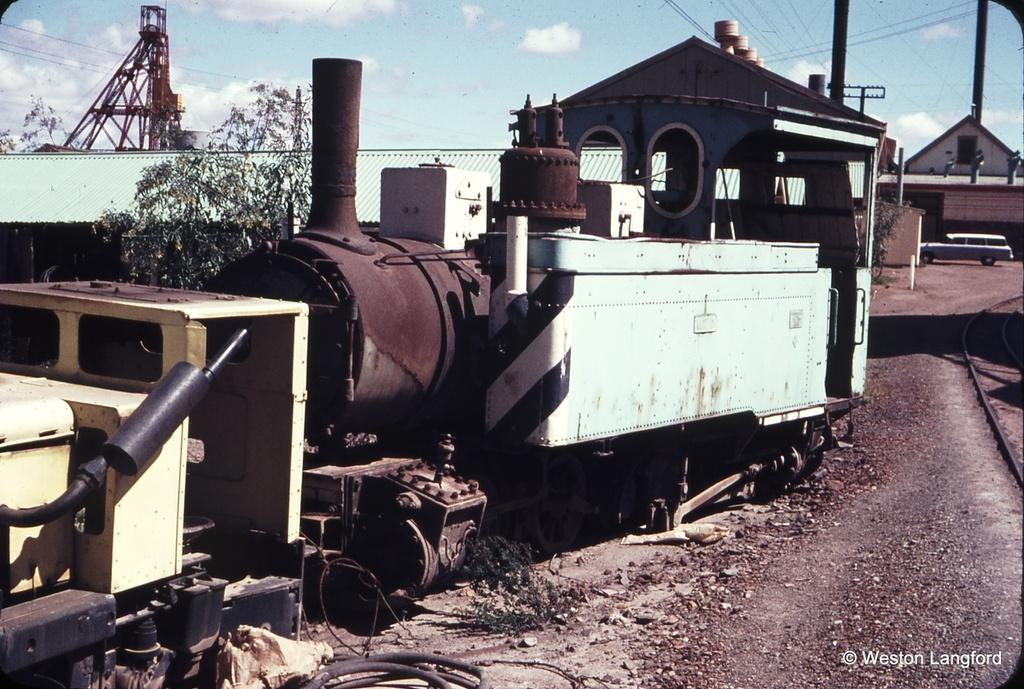What is the main subject of the image? The main subject of the image is a scrapped vehicle. What can be seen behind the vehicle in the image? There is a house behind the vehicle. What is located in front of the house in the image? There is a car in front of the house. What is on the left side of the image? There is a tower on the left side of the image. Can you tell me how many toads are sitting on the car in the image? There are no toads present in the image; it only features a scrapped vehicle, a house, a car, and a tower. 